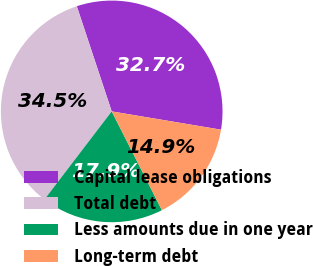<chart> <loc_0><loc_0><loc_500><loc_500><pie_chart><fcel>Capital lease obligations<fcel>Total debt<fcel>Less amounts due in one year<fcel>Long-term debt<nl><fcel>32.74%<fcel>34.52%<fcel>17.86%<fcel>14.88%<nl></chart> 